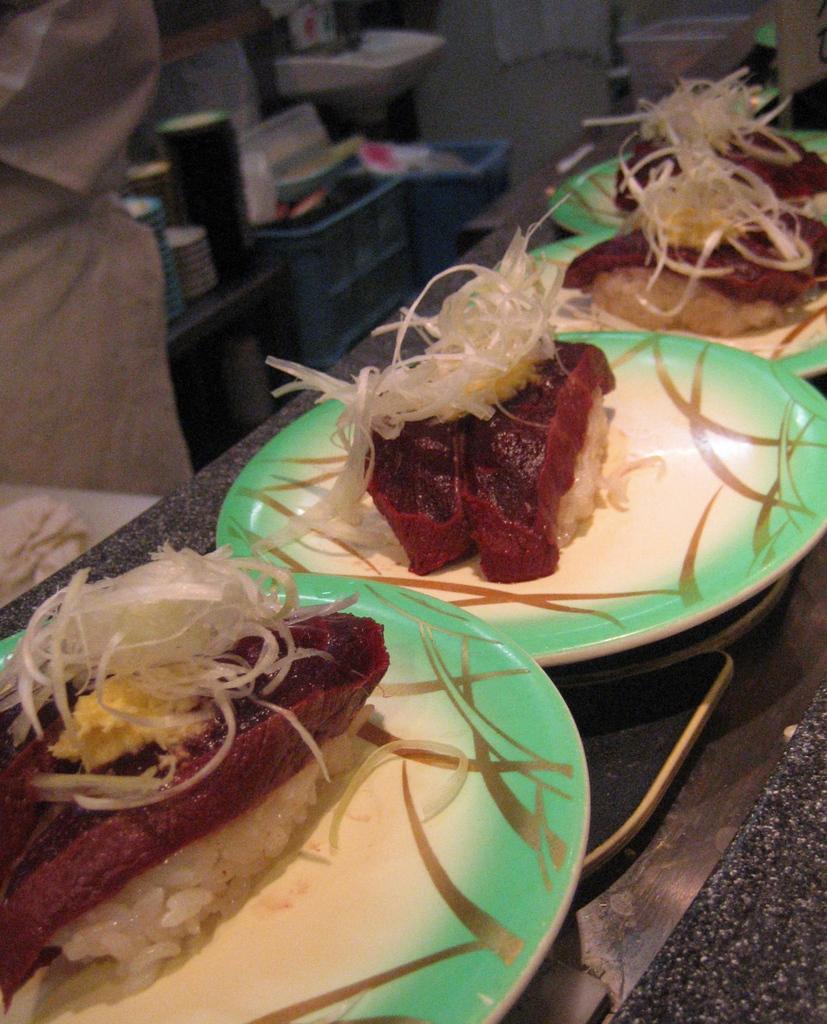How would you summarize this image in a sentence or two? In this image in front there are food items in a plate which was placed on the table. On the left side of the image there are few objects. 